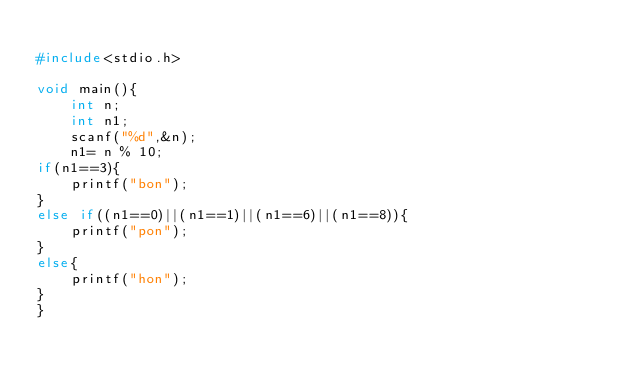Convert code to text. <code><loc_0><loc_0><loc_500><loc_500><_C_>
#include<stdio.h>

void main(){
    int n;
    int n1;
    scanf("%d",&n);
    n1= n % 10;
if(n1==3){
    printf("bon");
}
else if((n1==0)||(n1==1)||(n1==6)||(n1==8)){
    printf("pon");
}
else{
    printf("hon");
}
}</code> 